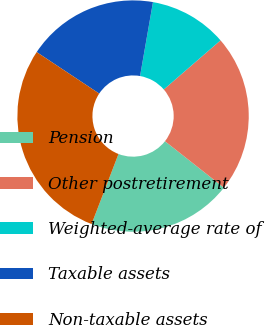Convert chart. <chart><loc_0><loc_0><loc_500><loc_500><pie_chart><fcel>Pension<fcel>Other postretirement<fcel>Weighted-average rate of<fcel>Taxable assets<fcel>Non-taxable assets<nl><fcel>20.21%<fcel>21.98%<fcel>10.89%<fcel>18.43%<fcel>28.49%<nl></chart> 